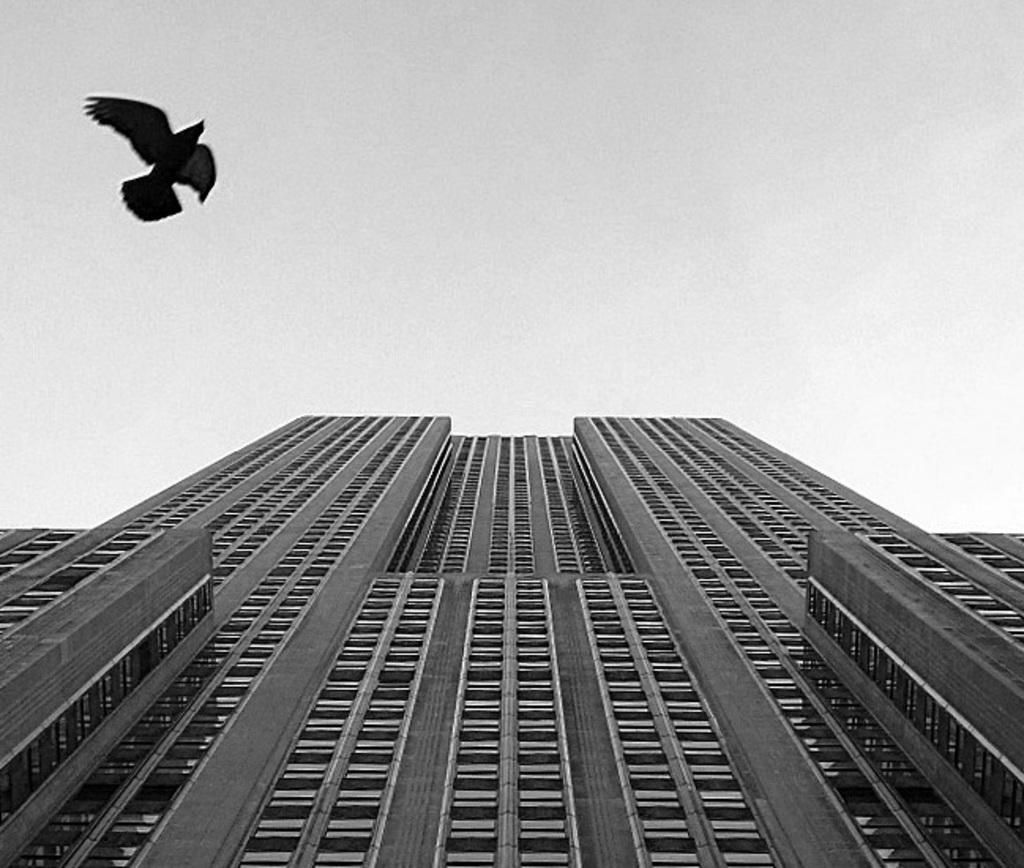What is the color scheme of the image? The image is black and white. What type of structure can be seen in the image? There is a building in the image. What type of animal is present in the image? There is a bird in the image. What part of the natural environment is visible in the image? The sky is visible in the background of the image. How many boys are playing in the image? There are no boys present in the image; it features a building, a bird, and a black and white color scheme. 